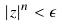Convert formula to latex. <formula><loc_0><loc_0><loc_500><loc_500>| z | ^ { n } < \epsilon</formula> 